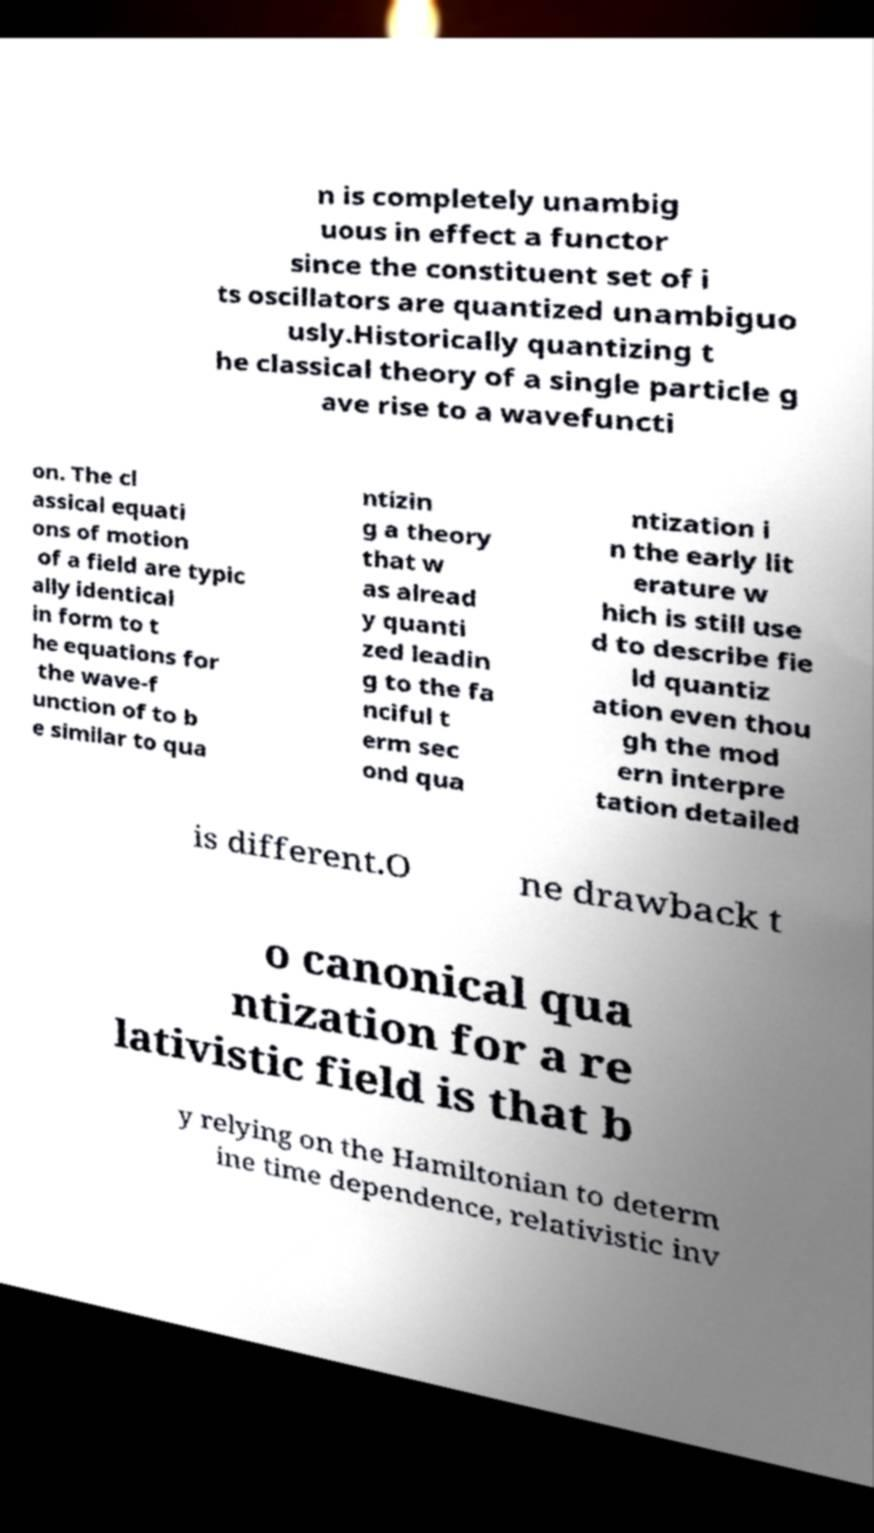What messages or text are displayed in this image? I need them in a readable, typed format. n is completely unambig uous in effect a functor since the constituent set of i ts oscillators are quantized unambiguo usly.Historically quantizing t he classical theory of a single particle g ave rise to a wavefuncti on. The cl assical equati ons of motion of a field are typic ally identical in form to t he equations for the wave-f unction of to b e similar to qua ntizin g a theory that w as alread y quanti zed leadin g to the fa nciful t erm sec ond qua ntization i n the early lit erature w hich is still use d to describe fie ld quantiz ation even thou gh the mod ern interpre tation detailed is different.O ne drawback t o canonical qua ntization for a re lativistic field is that b y relying on the Hamiltonian to determ ine time dependence, relativistic inv 